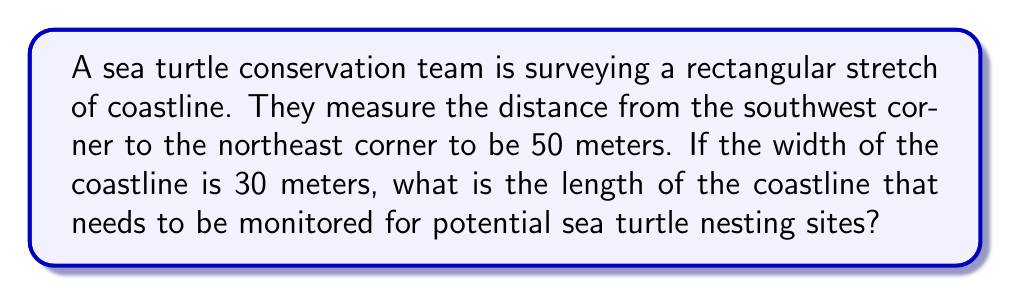Provide a solution to this math problem. Let's approach this step-by-step using the Pythagorean theorem:

1) Let's define our variables:
   - Let $l$ be the length of the coastline
   - The width is given as 30 meters
   - The diagonal is given as 50 meters

2) We can visualize this as a right triangle, where:
   - The width forms one side
   - The length forms another side
   - The diagonal forms the hypotenuse

3) The Pythagorean theorem states that in a right triangle:
   $a^2 + b^2 = c^2$
   where $c$ is the hypotenuse and $a$ and $b$ are the other two sides

4) Applying this to our problem:
   $l^2 + 30^2 = 50^2$

5) Let's solve for $l$:
   $l^2 = 50^2 - 30^2$
   $l^2 = 2500 - 900$
   $l^2 = 1600$

6) Taking the square root of both sides:
   $l = \sqrt{1600} = 40$

Therefore, the length of the coastline is 40 meters.

[asy]
unitsize(2mm);
draw((0,0)--(30,0)--(30,40)--(0,40)--cycle);
draw((0,0)--(30,40));
label("50m", (15,20), SE);
label("30m", (15,0), S);
label("40m", (30,20), E);
[/asy]
Answer: $40$ meters 